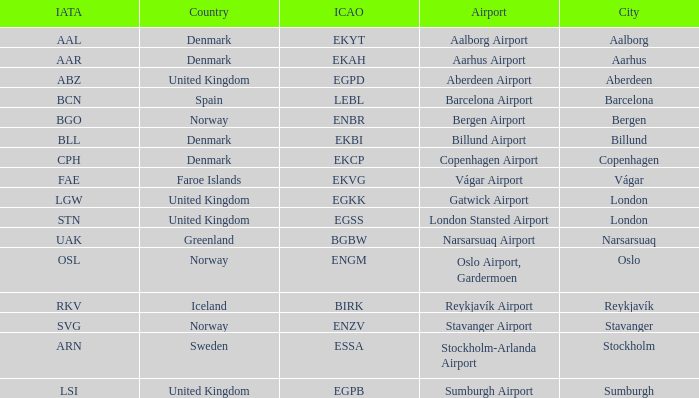What airport has an IATA of ARN? Stockholm-Arlanda Airport. 